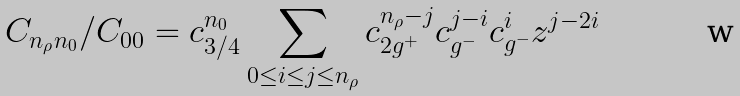Convert formula to latex. <formula><loc_0><loc_0><loc_500><loc_500>C _ { n _ { \rho } n _ { 0 } } / { C _ { 0 0 } } = c _ { 3 / 4 } ^ { n _ { 0 } } \sum _ { 0 \leq i \leq j \leq n _ { \rho } } c _ { 2 g ^ { + } } ^ { n _ { \rho } - j } c _ { g ^ { - } } ^ { j - i } c _ { g ^ { - } } ^ { i } z ^ { j - 2 i }</formula> 